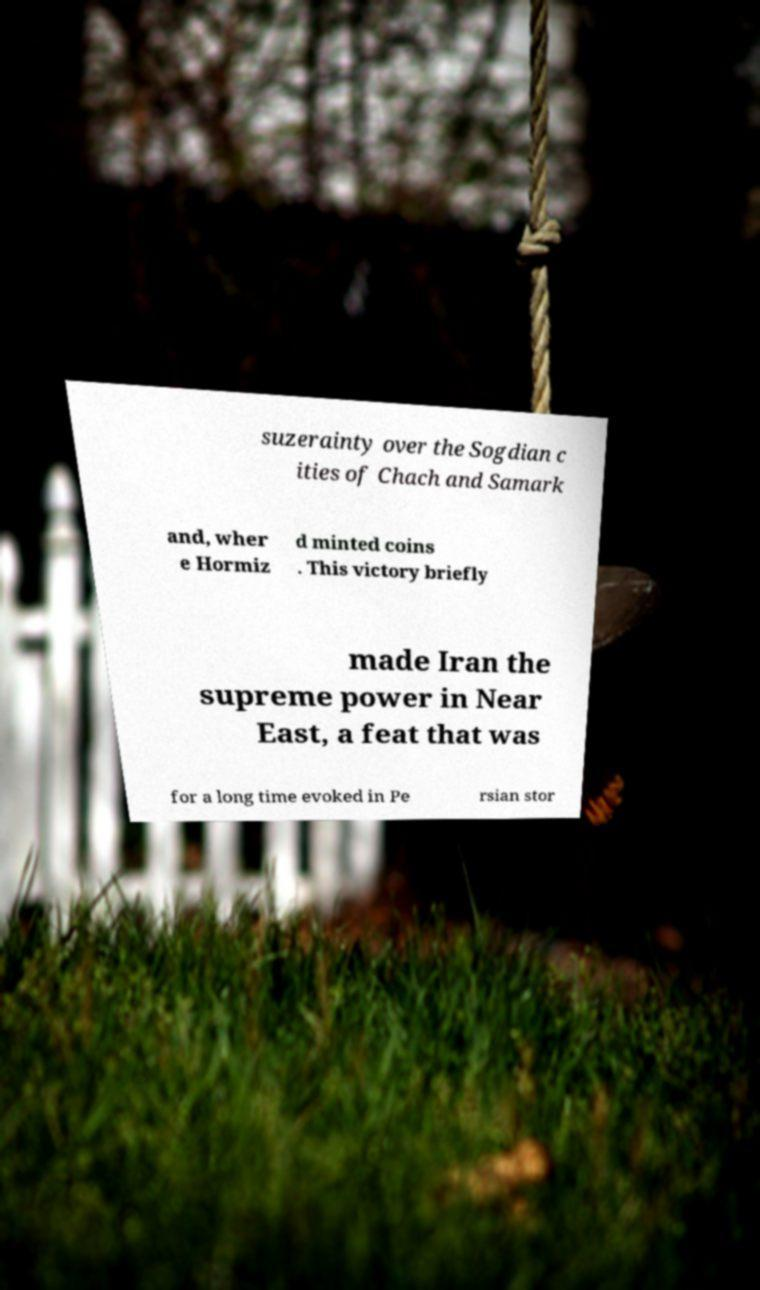I need the written content from this picture converted into text. Can you do that? suzerainty over the Sogdian c ities of Chach and Samark and, wher e Hormiz d minted coins . This victory briefly made Iran the supreme power in Near East, a feat that was for a long time evoked in Pe rsian stor 